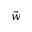Convert formula to latex. <formula><loc_0><loc_0><loc_500><loc_500>\vec { w }</formula> 